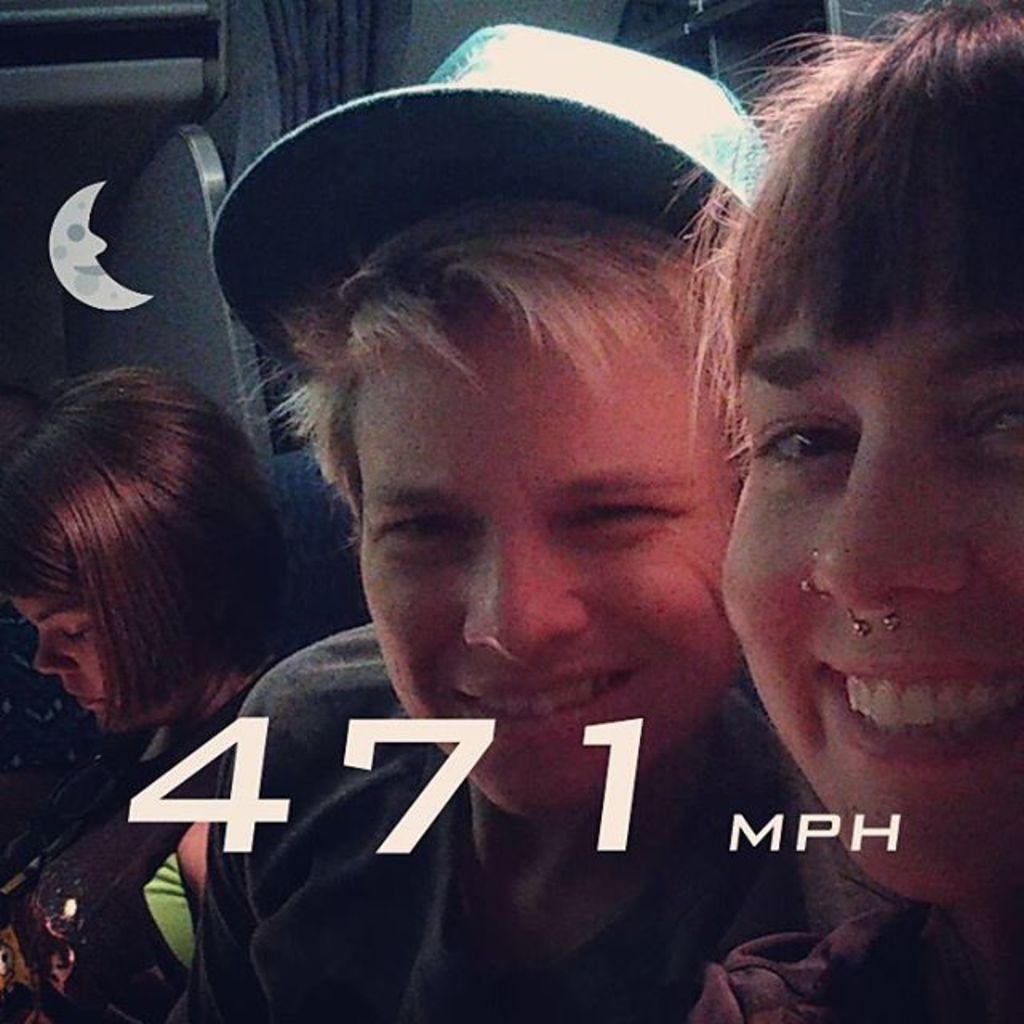Who is present in the image? There is a woman in the image. What is the woman doing in the image? The woman is smiling in the image. Can you describe another person in the image? There is a person wearing a cap in the image. What can be seen in the background of the image? There is another woman and curtains visible in the background of the image. What type of pancake is being served to the woman in the image? There is no pancake present in the image. How far away is the cake from the woman in the image? There are no cakes present in the image, so it is not possible to determine the distance between the woman and a cake. 